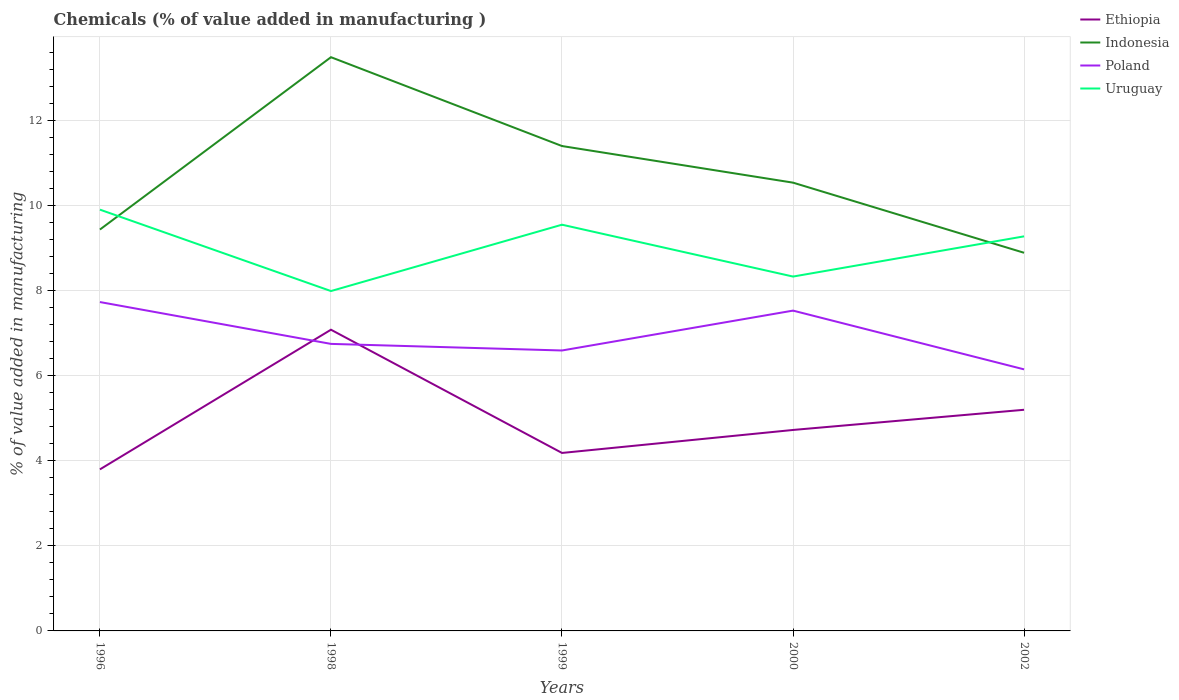Does the line corresponding to Uruguay intersect with the line corresponding to Poland?
Offer a terse response. No. Is the number of lines equal to the number of legend labels?
Provide a succinct answer. Yes. Across all years, what is the maximum value added in manufacturing chemicals in Uruguay?
Keep it short and to the point. 7.99. What is the total value added in manufacturing chemicals in Poland in the graph?
Your response must be concise. -0.78. What is the difference between the highest and the second highest value added in manufacturing chemicals in Indonesia?
Your response must be concise. 4.6. What is the difference between the highest and the lowest value added in manufacturing chemicals in Uruguay?
Keep it short and to the point. 3. What is the title of the graph?
Your response must be concise. Chemicals (% of value added in manufacturing ). Does "Guam" appear as one of the legend labels in the graph?
Provide a short and direct response. No. What is the label or title of the Y-axis?
Offer a terse response. % of value added in manufacturing. What is the % of value added in manufacturing in Ethiopia in 1996?
Your answer should be compact. 3.8. What is the % of value added in manufacturing of Indonesia in 1996?
Ensure brevity in your answer.  9.43. What is the % of value added in manufacturing in Poland in 1996?
Offer a terse response. 7.73. What is the % of value added in manufacturing of Uruguay in 1996?
Offer a very short reply. 9.9. What is the % of value added in manufacturing in Ethiopia in 1998?
Keep it short and to the point. 7.08. What is the % of value added in manufacturing in Indonesia in 1998?
Offer a very short reply. 13.48. What is the % of value added in manufacturing of Poland in 1998?
Offer a terse response. 6.74. What is the % of value added in manufacturing of Uruguay in 1998?
Ensure brevity in your answer.  7.99. What is the % of value added in manufacturing of Ethiopia in 1999?
Offer a very short reply. 4.18. What is the % of value added in manufacturing in Indonesia in 1999?
Offer a very short reply. 11.39. What is the % of value added in manufacturing in Poland in 1999?
Your answer should be very brief. 6.59. What is the % of value added in manufacturing of Uruguay in 1999?
Make the answer very short. 9.54. What is the % of value added in manufacturing of Ethiopia in 2000?
Provide a succinct answer. 4.72. What is the % of value added in manufacturing in Indonesia in 2000?
Your response must be concise. 10.53. What is the % of value added in manufacturing in Poland in 2000?
Your response must be concise. 7.53. What is the % of value added in manufacturing of Uruguay in 2000?
Your answer should be very brief. 8.33. What is the % of value added in manufacturing in Ethiopia in 2002?
Keep it short and to the point. 5.2. What is the % of value added in manufacturing in Indonesia in 2002?
Offer a terse response. 8.88. What is the % of value added in manufacturing of Poland in 2002?
Provide a short and direct response. 6.15. What is the % of value added in manufacturing in Uruguay in 2002?
Provide a succinct answer. 9.27. Across all years, what is the maximum % of value added in manufacturing of Ethiopia?
Provide a succinct answer. 7.08. Across all years, what is the maximum % of value added in manufacturing in Indonesia?
Provide a succinct answer. 13.48. Across all years, what is the maximum % of value added in manufacturing of Poland?
Keep it short and to the point. 7.73. Across all years, what is the maximum % of value added in manufacturing of Uruguay?
Make the answer very short. 9.9. Across all years, what is the minimum % of value added in manufacturing of Ethiopia?
Keep it short and to the point. 3.8. Across all years, what is the minimum % of value added in manufacturing of Indonesia?
Provide a short and direct response. 8.88. Across all years, what is the minimum % of value added in manufacturing of Poland?
Your answer should be compact. 6.15. Across all years, what is the minimum % of value added in manufacturing in Uruguay?
Ensure brevity in your answer.  7.99. What is the total % of value added in manufacturing in Ethiopia in the graph?
Provide a short and direct response. 24.97. What is the total % of value added in manufacturing of Indonesia in the graph?
Offer a very short reply. 53.72. What is the total % of value added in manufacturing in Poland in the graph?
Give a very brief answer. 34.73. What is the total % of value added in manufacturing in Uruguay in the graph?
Offer a very short reply. 45.03. What is the difference between the % of value added in manufacturing in Ethiopia in 1996 and that in 1998?
Give a very brief answer. -3.28. What is the difference between the % of value added in manufacturing of Indonesia in 1996 and that in 1998?
Make the answer very short. -4.05. What is the difference between the % of value added in manufacturing in Poland in 1996 and that in 1998?
Ensure brevity in your answer.  0.98. What is the difference between the % of value added in manufacturing in Uruguay in 1996 and that in 1998?
Provide a short and direct response. 1.91. What is the difference between the % of value added in manufacturing of Ethiopia in 1996 and that in 1999?
Give a very brief answer. -0.39. What is the difference between the % of value added in manufacturing in Indonesia in 1996 and that in 1999?
Offer a very short reply. -1.96. What is the difference between the % of value added in manufacturing of Poland in 1996 and that in 1999?
Your answer should be very brief. 1.14. What is the difference between the % of value added in manufacturing in Uruguay in 1996 and that in 1999?
Your answer should be very brief. 0.35. What is the difference between the % of value added in manufacturing of Ethiopia in 1996 and that in 2000?
Make the answer very short. -0.93. What is the difference between the % of value added in manufacturing in Indonesia in 1996 and that in 2000?
Keep it short and to the point. -1.1. What is the difference between the % of value added in manufacturing of Poland in 1996 and that in 2000?
Make the answer very short. 0.2. What is the difference between the % of value added in manufacturing of Uruguay in 1996 and that in 2000?
Your answer should be compact. 1.57. What is the difference between the % of value added in manufacturing of Ethiopia in 1996 and that in 2002?
Offer a terse response. -1.4. What is the difference between the % of value added in manufacturing in Indonesia in 1996 and that in 2002?
Ensure brevity in your answer.  0.55. What is the difference between the % of value added in manufacturing in Poland in 1996 and that in 2002?
Give a very brief answer. 1.58. What is the difference between the % of value added in manufacturing in Uruguay in 1996 and that in 2002?
Offer a terse response. 0.63. What is the difference between the % of value added in manufacturing of Ethiopia in 1998 and that in 1999?
Provide a short and direct response. 2.9. What is the difference between the % of value added in manufacturing of Indonesia in 1998 and that in 1999?
Ensure brevity in your answer.  2.09. What is the difference between the % of value added in manufacturing of Poland in 1998 and that in 1999?
Your answer should be compact. 0.15. What is the difference between the % of value added in manufacturing in Uruguay in 1998 and that in 1999?
Provide a succinct answer. -1.56. What is the difference between the % of value added in manufacturing of Ethiopia in 1998 and that in 2000?
Your answer should be compact. 2.36. What is the difference between the % of value added in manufacturing of Indonesia in 1998 and that in 2000?
Ensure brevity in your answer.  2.95. What is the difference between the % of value added in manufacturing of Poland in 1998 and that in 2000?
Give a very brief answer. -0.78. What is the difference between the % of value added in manufacturing in Uruguay in 1998 and that in 2000?
Offer a very short reply. -0.34. What is the difference between the % of value added in manufacturing of Ethiopia in 1998 and that in 2002?
Your answer should be compact. 1.88. What is the difference between the % of value added in manufacturing of Indonesia in 1998 and that in 2002?
Give a very brief answer. 4.6. What is the difference between the % of value added in manufacturing of Poland in 1998 and that in 2002?
Your answer should be very brief. 0.6. What is the difference between the % of value added in manufacturing in Uruguay in 1998 and that in 2002?
Provide a short and direct response. -1.29. What is the difference between the % of value added in manufacturing of Ethiopia in 1999 and that in 2000?
Your answer should be compact. -0.54. What is the difference between the % of value added in manufacturing in Indonesia in 1999 and that in 2000?
Give a very brief answer. 0.86. What is the difference between the % of value added in manufacturing in Poland in 1999 and that in 2000?
Your answer should be very brief. -0.94. What is the difference between the % of value added in manufacturing in Uruguay in 1999 and that in 2000?
Offer a very short reply. 1.22. What is the difference between the % of value added in manufacturing in Ethiopia in 1999 and that in 2002?
Your answer should be compact. -1.01. What is the difference between the % of value added in manufacturing of Indonesia in 1999 and that in 2002?
Your response must be concise. 2.51. What is the difference between the % of value added in manufacturing in Poland in 1999 and that in 2002?
Your response must be concise. 0.44. What is the difference between the % of value added in manufacturing in Uruguay in 1999 and that in 2002?
Your response must be concise. 0.27. What is the difference between the % of value added in manufacturing in Ethiopia in 2000 and that in 2002?
Provide a succinct answer. -0.47. What is the difference between the % of value added in manufacturing of Indonesia in 2000 and that in 2002?
Your response must be concise. 1.65. What is the difference between the % of value added in manufacturing of Poland in 2000 and that in 2002?
Ensure brevity in your answer.  1.38. What is the difference between the % of value added in manufacturing in Uruguay in 2000 and that in 2002?
Provide a succinct answer. -0.94. What is the difference between the % of value added in manufacturing of Ethiopia in 1996 and the % of value added in manufacturing of Indonesia in 1998?
Offer a very short reply. -9.69. What is the difference between the % of value added in manufacturing of Ethiopia in 1996 and the % of value added in manufacturing of Poland in 1998?
Offer a terse response. -2.95. What is the difference between the % of value added in manufacturing of Ethiopia in 1996 and the % of value added in manufacturing of Uruguay in 1998?
Keep it short and to the point. -4.19. What is the difference between the % of value added in manufacturing of Indonesia in 1996 and the % of value added in manufacturing of Poland in 1998?
Provide a short and direct response. 2.69. What is the difference between the % of value added in manufacturing in Indonesia in 1996 and the % of value added in manufacturing in Uruguay in 1998?
Make the answer very short. 1.45. What is the difference between the % of value added in manufacturing in Poland in 1996 and the % of value added in manufacturing in Uruguay in 1998?
Your answer should be very brief. -0.26. What is the difference between the % of value added in manufacturing in Ethiopia in 1996 and the % of value added in manufacturing in Indonesia in 1999?
Your answer should be very brief. -7.6. What is the difference between the % of value added in manufacturing of Ethiopia in 1996 and the % of value added in manufacturing of Poland in 1999?
Provide a succinct answer. -2.79. What is the difference between the % of value added in manufacturing of Ethiopia in 1996 and the % of value added in manufacturing of Uruguay in 1999?
Give a very brief answer. -5.75. What is the difference between the % of value added in manufacturing of Indonesia in 1996 and the % of value added in manufacturing of Poland in 1999?
Your answer should be very brief. 2.84. What is the difference between the % of value added in manufacturing of Indonesia in 1996 and the % of value added in manufacturing of Uruguay in 1999?
Offer a very short reply. -0.11. What is the difference between the % of value added in manufacturing in Poland in 1996 and the % of value added in manufacturing in Uruguay in 1999?
Provide a succinct answer. -1.82. What is the difference between the % of value added in manufacturing of Ethiopia in 1996 and the % of value added in manufacturing of Indonesia in 2000?
Make the answer very short. -6.74. What is the difference between the % of value added in manufacturing in Ethiopia in 1996 and the % of value added in manufacturing in Poland in 2000?
Your answer should be compact. -3.73. What is the difference between the % of value added in manufacturing in Ethiopia in 1996 and the % of value added in manufacturing in Uruguay in 2000?
Your answer should be compact. -4.53. What is the difference between the % of value added in manufacturing of Indonesia in 1996 and the % of value added in manufacturing of Poland in 2000?
Ensure brevity in your answer.  1.9. What is the difference between the % of value added in manufacturing in Indonesia in 1996 and the % of value added in manufacturing in Uruguay in 2000?
Offer a very short reply. 1.1. What is the difference between the % of value added in manufacturing in Poland in 1996 and the % of value added in manufacturing in Uruguay in 2000?
Ensure brevity in your answer.  -0.6. What is the difference between the % of value added in manufacturing of Ethiopia in 1996 and the % of value added in manufacturing of Indonesia in 2002?
Keep it short and to the point. -5.09. What is the difference between the % of value added in manufacturing of Ethiopia in 1996 and the % of value added in manufacturing of Poland in 2002?
Give a very brief answer. -2.35. What is the difference between the % of value added in manufacturing of Ethiopia in 1996 and the % of value added in manufacturing of Uruguay in 2002?
Keep it short and to the point. -5.48. What is the difference between the % of value added in manufacturing in Indonesia in 1996 and the % of value added in manufacturing in Poland in 2002?
Provide a succinct answer. 3.29. What is the difference between the % of value added in manufacturing in Indonesia in 1996 and the % of value added in manufacturing in Uruguay in 2002?
Your answer should be very brief. 0.16. What is the difference between the % of value added in manufacturing of Poland in 1996 and the % of value added in manufacturing of Uruguay in 2002?
Offer a very short reply. -1.54. What is the difference between the % of value added in manufacturing of Ethiopia in 1998 and the % of value added in manufacturing of Indonesia in 1999?
Ensure brevity in your answer.  -4.32. What is the difference between the % of value added in manufacturing of Ethiopia in 1998 and the % of value added in manufacturing of Poland in 1999?
Your answer should be very brief. 0.49. What is the difference between the % of value added in manufacturing in Ethiopia in 1998 and the % of value added in manufacturing in Uruguay in 1999?
Your answer should be compact. -2.47. What is the difference between the % of value added in manufacturing in Indonesia in 1998 and the % of value added in manufacturing in Poland in 1999?
Make the answer very short. 6.89. What is the difference between the % of value added in manufacturing in Indonesia in 1998 and the % of value added in manufacturing in Uruguay in 1999?
Your answer should be compact. 3.94. What is the difference between the % of value added in manufacturing in Poland in 1998 and the % of value added in manufacturing in Uruguay in 1999?
Offer a terse response. -2.8. What is the difference between the % of value added in manufacturing of Ethiopia in 1998 and the % of value added in manufacturing of Indonesia in 2000?
Provide a succinct answer. -3.46. What is the difference between the % of value added in manufacturing of Ethiopia in 1998 and the % of value added in manufacturing of Poland in 2000?
Offer a terse response. -0.45. What is the difference between the % of value added in manufacturing in Ethiopia in 1998 and the % of value added in manufacturing in Uruguay in 2000?
Offer a terse response. -1.25. What is the difference between the % of value added in manufacturing of Indonesia in 1998 and the % of value added in manufacturing of Poland in 2000?
Your answer should be very brief. 5.95. What is the difference between the % of value added in manufacturing in Indonesia in 1998 and the % of value added in manufacturing in Uruguay in 2000?
Your answer should be compact. 5.15. What is the difference between the % of value added in manufacturing in Poland in 1998 and the % of value added in manufacturing in Uruguay in 2000?
Offer a very short reply. -1.58. What is the difference between the % of value added in manufacturing of Ethiopia in 1998 and the % of value added in manufacturing of Indonesia in 2002?
Provide a short and direct response. -1.81. What is the difference between the % of value added in manufacturing in Ethiopia in 1998 and the % of value added in manufacturing in Poland in 2002?
Keep it short and to the point. 0.93. What is the difference between the % of value added in manufacturing of Ethiopia in 1998 and the % of value added in manufacturing of Uruguay in 2002?
Provide a succinct answer. -2.19. What is the difference between the % of value added in manufacturing in Indonesia in 1998 and the % of value added in manufacturing in Poland in 2002?
Offer a very short reply. 7.33. What is the difference between the % of value added in manufacturing in Indonesia in 1998 and the % of value added in manufacturing in Uruguay in 2002?
Keep it short and to the point. 4.21. What is the difference between the % of value added in manufacturing in Poland in 1998 and the % of value added in manufacturing in Uruguay in 2002?
Ensure brevity in your answer.  -2.53. What is the difference between the % of value added in manufacturing in Ethiopia in 1999 and the % of value added in manufacturing in Indonesia in 2000?
Your response must be concise. -6.35. What is the difference between the % of value added in manufacturing in Ethiopia in 1999 and the % of value added in manufacturing in Poland in 2000?
Give a very brief answer. -3.34. What is the difference between the % of value added in manufacturing of Ethiopia in 1999 and the % of value added in manufacturing of Uruguay in 2000?
Ensure brevity in your answer.  -4.14. What is the difference between the % of value added in manufacturing of Indonesia in 1999 and the % of value added in manufacturing of Poland in 2000?
Provide a short and direct response. 3.87. What is the difference between the % of value added in manufacturing of Indonesia in 1999 and the % of value added in manufacturing of Uruguay in 2000?
Offer a terse response. 3.07. What is the difference between the % of value added in manufacturing of Poland in 1999 and the % of value added in manufacturing of Uruguay in 2000?
Keep it short and to the point. -1.74. What is the difference between the % of value added in manufacturing in Ethiopia in 1999 and the % of value added in manufacturing in Indonesia in 2002?
Your response must be concise. -4.7. What is the difference between the % of value added in manufacturing of Ethiopia in 1999 and the % of value added in manufacturing of Poland in 2002?
Offer a very short reply. -1.96. What is the difference between the % of value added in manufacturing in Ethiopia in 1999 and the % of value added in manufacturing in Uruguay in 2002?
Provide a short and direct response. -5.09. What is the difference between the % of value added in manufacturing in Indonesia in 1999 and the % of value added in manufacturing in Poland in 2002?
Keep it short and to the point. 5.25. What is the difference between the % of value added in manufacturing of Indonesia in 1999 and the % of value added in manufacturing of Uruguay in 2002?
Your answer should be compact. 2.12. What is the difference between the % of value added in manufacturing in Poland in 1999 and the % of value added in manufacturing in Uruguay in 2002?
Your answer should be compact. -2.68. What is the difference between the % of value added in manufacturing in Ethiopia in 2000 and the % of value added in manufacturing in Indonesia in 2002?
Offer a terse response. -4.16. What is the difference between the % of value added in manufacturing of Ethiopia in 2000 and the % of value added in manufacturing of Poland in 2002?
Make the answer very short. -1.42. What is the difference between the % of value added in manufacturing of Ethiopia in 2000 and the % of value added in manufacturing of Uruguay in 2002?
Give a very brief answer. -4.55. What is the difference between the % of value added in manufacturing of Indonesia in 2000 and the % of value added in manufacturing of Poland in 2002?
Keep it short and to the point. 4.39. What is the difference between the % of value added in manufacturing in Indonesia in 2000 and the % of value added in manufacturing in Uruguay in 2002?
Offer a very short reply. 1.26. What is the difference between the % of value added in manufacturing in Poland in 2000 and the % of value added in manufacturing in Uruguay in 2002?
Offer a terse response. -1.75. What is the average % of value added in manufacturing in Ethiopia per year?
Your answer should be very brief. 4.99. What is the average % of value added in manufacturing of Indonesia per year?
Give a very brief answer. 10.74. What is the average % of value added in manufacturing of Poland per year?
Provide a short and direct response. 6.95. What is the average % of value added in manufacturing in Uruguay per year?
Provide a succinct answer. 9.01. In the year 1996, what is the difference between the % of value added in manufacturing of Ethiopia and % of value added in manufacturing of Indonesia?
Make the answer very short. -5.64. In the year 1996, what is the difference between the % of value added in manufacturing of Ethiopia and % of value added in manufacturing of Poland?
Your answer should be compact. -3.93. In the year 1996, what is the difference between the % of value added in manufacturing in Ethiopia and % of value added in manufacturing in Uruguay?
Offer a terse response. -6.1. In the year 1996, what is the difference between the % of value added in manufacturing in Indonesia and % of value added in manufacturing in Poland?
Provide a short and direct response. 1.7. In the year 1996, what is the difference between the % of value added in manufacturing in Indonesia and % of value added in manufacturing in Uruguay?
Your response must be concise. -0.47. In the year 1996, what is the difference between the % of value added in manufacturing in Poland and % of value added in manufacturing in Uruguay?
Your answer should be very brief. -2.17. In the year 1998, what is the difference between the % of value added in manufacturing of Ethiopia and % of value added in manufacturing of Indonesia?
Make the answer very short. -6.4. In the year 1998, what is the difference between the % of value added in manufacturing of Ethiopia and % of value added in manufacturing of Poland?
Your response must be concise. 0.33. In the year 1998, what is the difference between the % of value added in manufacturing in Ethiopia and % of value added in manufacturing in Uruguay?
Keep it short and to the point. -0.91. In the year 1998, what is the difference between the % of value added in manufacturing in Indonesia and % of value added in manufacturing in Poland?
Provide a succinct answer. 6.74. In the year 1998, what is the difference between the % of value added in manufacturing in Indonesia and % of value added in manufacturing in Uruguay?
Your response must be concise. 5.49. In the year 1998, what is the difference between the % of value added in manufacturing in Poland and % of value added in manufacturing in Uruguay?
Provide a short and direct response. -1.24. In the year 1999, what is the difference between the % of value added in manufacturing in Ethiopia and % of value added in manufacturing in Indonesia?
Provide a succinct answer. -7.21. In the year 1999, what is the difference between the % of value added in manufacturing in Ethiopia and % of value added in manufacturing in Poland?
Offer a very short reply. -2.41. In the year 1999, what is the difference between the % of value added in manufacturing of Ethiopia and % of value added in manufacturing of Uruguay?
Provide a short and direct response. -5.36. In the year 1999, what is the difference between the % of value added in manufacturing of Indonesia and % of value added in manufacturing of Poland?
Provide a succinct answer. 4.8. In the year 1999, what is the difference between the % of value added in manufacturing in Indonesia and % of value added in manufacturing in Uruguay?
Ensure brevity in your answer.  1.85. In the year 1999, what is the difference between the % of value added in manufacturing in Poland and % of value added in manufacturing in Uruguay?
Make the answer very short. -2.96. In the year 2000, what is the difference between the % of value added in manufacturing of Ethiopia and % of value added in manufacturing of Indonesia?
Ensure brevity in your answer.  -5.81. In the year 2000, what is the difference between the % of value added in manufacturing in Ethiopia and % of value added in manufacturing in Poland?
Ensure brevity in your answer.  -2.8. In the year 2000, what is the difference between the % of value added in manufacturing of Ethiopia and % of value added in manufacturing of Uruguay?
Offer a terse response. -3.6. In the year 2000, what is the difference between the % of value added in manufacturing of Indonesia and % of value added in manufacturing of Poland?
Your answer should be very brief. 3.01. In the year 2000, what is the difference between the % of value added in manufacturing in Indonesia and % of value added in manufacturing in Uruguay?
Give a very brief answer. 2.21. In the year 2000, what is the difference between the % of value added in manufacturing in Poland and % of value added in manufacturing in Uruguay?
Your response must be concise. -0.8. In the year 2002, what is the difference between the % of value added in manufacturing of Ethiopia and % of value added in manufacturing of Indonesia?
Your answer should be very brief. -3.69. In the year 2002, what is the difference between the % of value added in manufacturing of Ethiopia and % of value added in manufacturing of Poland?
Keep it short and to the point. -0.95. In the year 2002, what is the difference between the % of value added in manufacturing in Ethiopia and % of value added in manufacturing in Uruguay?
Your answer should be very brief. -4.08. In the year 2002, what is the difference between the % of value added in manufacturing of Indonesia and % of value added in manufacturing of Poland?
Your answer should be very brief. 2.74. In the year 2002, what is the difference between the % of value added in manufacturing of Indonesia and % of value added in manufacturing of Uruguay?
Provide a succinct answer. -0.39. In the year 2002, what is the difference between the % of value added in manufacturing in Poland and % of value added in manufacturing in Uruguay?
Make the answer very short. -3.13. What is the ratio of the % of value added in manufacturing in Ethiopia in 1996 to that in 1998?
Ensure brevity in your answer.  0.54. What is the ratio of the % of value added in manufacturing of Indonesia in 1996 to that in 1998?
Your answer should be very brief. 0.7. What is the ratio of the % of value added in manufacturing in Poland in 1996 to that in 1998?
Give a very brief answer. 1.15. What is the ratio of the % of value added in manufacturing of Uruguay in 1996 to that in 1998?
Provide a succinct answer. 1.24. What is the ratio of the % of value added in manufacturing in Ethiopia in 1996 to that in 1999?
Provide a succinct answer. 0.91. What is the ratio of the % of value added in manufacturing of Indonesia in 1996 to that in 1999?
Keep it short and to the point. 0.83. What is the ratio of the % of value added in manufacturing in Poland in 1996 to that in 1999?
Provide a short and direct response. 1.17. What is the ratio of the % of value added in manufacturing in Uruguay in 1996 to that in 1999?
Provide a short and direct response. 1.04. What is the ratio of the % of value added in manufacturing of Ethiopia in 1996 to that in 2000?
Provide a succinct answer. 0.8. What is the ratio of the % of value added in manufacturing of Indonesia in 1996 to that in 2000?
Make the answer very short. 0.9. What is the ratio of the % of value added in manufacturing in Poland in 1996 to that in 2000?
Provide a succinct answer. 1.03. What is the ratio of the % of value added in manufacturing in Uruguay in 1996 to that in 2000?
Your answer should be compact. 1.19. What is the ratio of the % of value added in manufacturing in Ethiopia in 1996 to that in 2002?
Ensure brevity in your answer.  0.73. What is the ratio of the % of value added in manufacturing in Indonesia in 1996 to that in 2002?
Offer a very short reply. 1.06. What is the ratio of the % of value added in manufacturing in Poland in 1996 to that in 2002?
Your response must be concise. 1.26. What is the ratio of the % of value added in manufacturing in Uruguay in 1996 to that in 2002?
Make the answer very short. 1.07. What is the ratio of the % of value added in manufacturing in Ethiopia in 1998 to that in 1999?
Offer a terse response. 1.69. What is the ratio of the % of value added in manufacturing of Indonesia in 1998 to that in 1999?
Provide a short and direct response. 1.18. What is the ratio of the % of value added in manufacturing in Poland in 1998 to that in 1999?
Make the answer very short. 1.02. What is the ratio of the % of value added in manufacturing of Uruguay in 1998 to that in 1999?
Your response must be concise. 0.84. What is the ratio of the % of value added in manufacturing of Ethiopia in 1998 to that in 2000?
Your answer should be compact. 1.5. What is the ratio of the % of value added in manufacturing in Indonesia in 1998 to that in 2000?
Your response must be concise. 1.28. What is the ratio of the % of value added in manufacturing in Poland in 1998 to that in 2000?
Keep it short and to the point. 0.9. What is the ratio of the % of value added in manufacturing in Uruguay in 1998 to that in 2000?
Your response must be concise. 0.96. What is the ratio of the % of value added in manufacturing of Ethiopia in 1998 to that in 2002?
Offer a very short reply. 1.36. What is the ratio of the % of value added in manufacturing in Indonesia in 1998 to that in 2002?
Ensure brevity in your answer.  1.52. What is the ratio of the % of value added in manufacturing in Poland in 1998 to that in 2002?
Your answer should be very brief. 1.1. What is the ratio of the % of value added in manufacturing of Uruguay in 1998 to that in 2002?
Ensure brevity in your answer.  0.86. What is the ratio of the % of value added in manufacturing in Ethiopia in 1999 to that in 2000?
Make the answer very short. 0.89. What is the ratio of the % of value added in manufacturing of Indonesia in 1999 to that in 2000?
Your answer should be very brief. 1.08. What is the ratio of the % of value added in manufacturing in Poland in 1999 to that in 2000?
Offer a terse response. 0.88. What is the ratio of the % of value added in manufacturing in Uruguay in 1999 to that in 2000?
Offer a terse response. 1.15. What is the ratio of the % of value added in manufacturing of Ethiopia in 1999 to that in 2002?
Your answer should be compact. 0.8. What is the ratio of the % of value added in manufacturing of Indonesia in 1999 to that in 2002?
Ensure brevity in your answer.  1.28. What is the ratio of the % of value added in manufacturing of Poland in 1999 to that in 2002?
Your response must be concise. 1.07. What is the ratio of the % of value added in manufacturing in Uruguay in 1999 to that in 2002?
Provide a succinct answer. 1.03. What is the ratio of the % of value added in manufacturing in Ethiopia in 2000 to that in 2002?
Provide a succinct answer. 0.91. What is the ratio of the % of value added in manufacturing in Indonesia in 2000 to that in 2002?
Your answer should be very brief. 1.19. What is the ratio of the % of value added in manufacturing in Poland in 2000 to that in 2002?
Give a very brief answer. 1.22. What is the ratio of the % of value added in manufacturing of Uruguay in 2000 to that in 2002?
Give a very brief answer. 0.9. What is the difference between the highest and the second highest % of value added in manufacturing in Ethiopia?
Keep it short and to the point. 1.88. What is the difference between the highest and the second highest % of value added in manufacturing in Indonesia?
Make the answer very short. 2.09. What is the difference between the highest and the second highest % of value added in manufacturing of Poland?
Provide a short and direct response. 0.2. What is the difference between the highest and the second highest % of value added in manufacturing of Uruguay?
Give a very brief answer. 0.35. What is the difference between the highest and the lowest % of value added in manufacturing in Ethiopia?
Your answer should be very brief. 3.28. What is the difference between the highest and the lowest % of value added in manufacturing in Indonesia?
Provide a short and direct response. 4.6. What is the difference between the highest and the lowest % of value added in manufacturing of Poland?
Keep it short and to the point. 1.58. What is the difference between the highest and the lowest % of value added in manufacturing of Uruguay?
Provide a short and direct response. 1.91. 